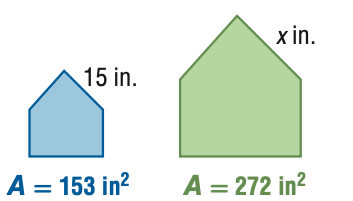Answer the mathemtical geometry problem and directly provide the correct option letter.
Question: For the pair of similar figures, use the given areas to find x.
Choices: A: 8.4 B: 11.3 C: 20.0 D: 26.7 C 